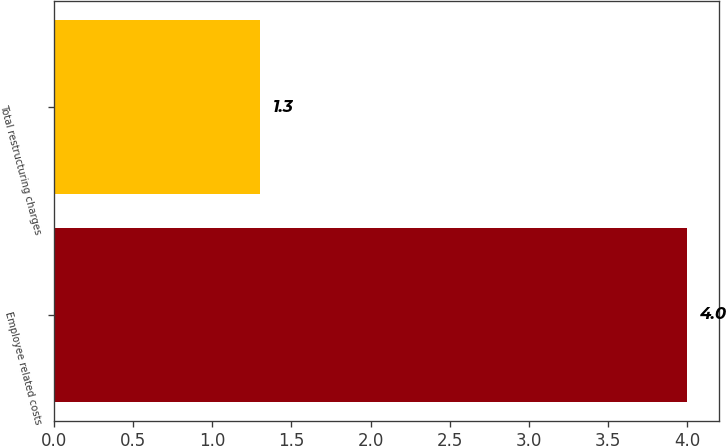<chart> <loc_0><loc_0><loc_500><loc_500><bar_chart><fcel>Employee related costs<fcel>Total restructuring charges<nl><fcel>4<fcel>1.3<nl></chart> 